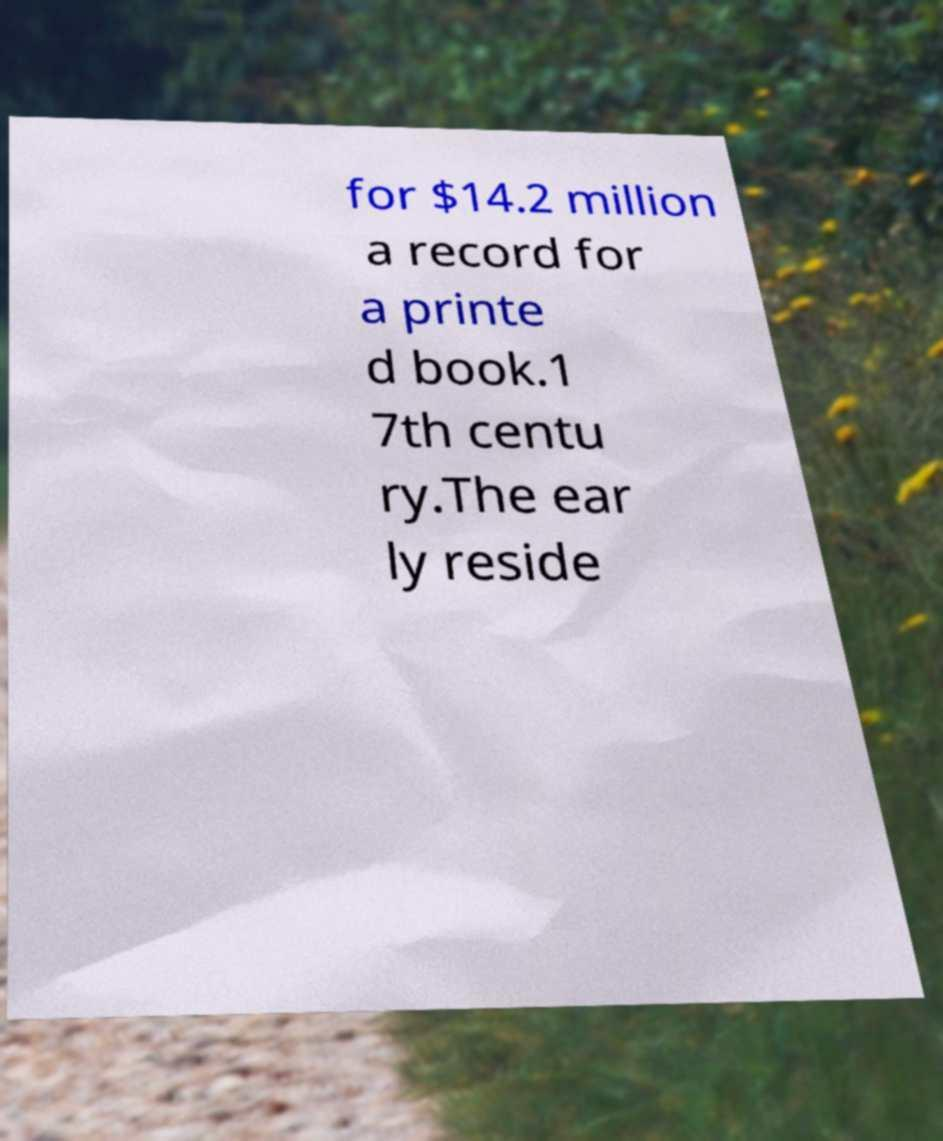Please read and relay the text visible in this image. What does it say? for $14.2 million a record for a printe d book.1 7th centu ry.The ear ly reside 